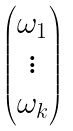Convert formula to latex. <formula><loc_0><loc_0><loc_500><loc_500>\begin{pmatrix} \omega _ { 1 } \\ \vdots \\ \omega _ { k } \end{pmatrix}</formula> 